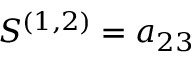<formula> <loc_0><loc_0><loc_500><loc_500>S ^ { ( 1 , 2 ) } = a _ { 2 3 }</formula> 